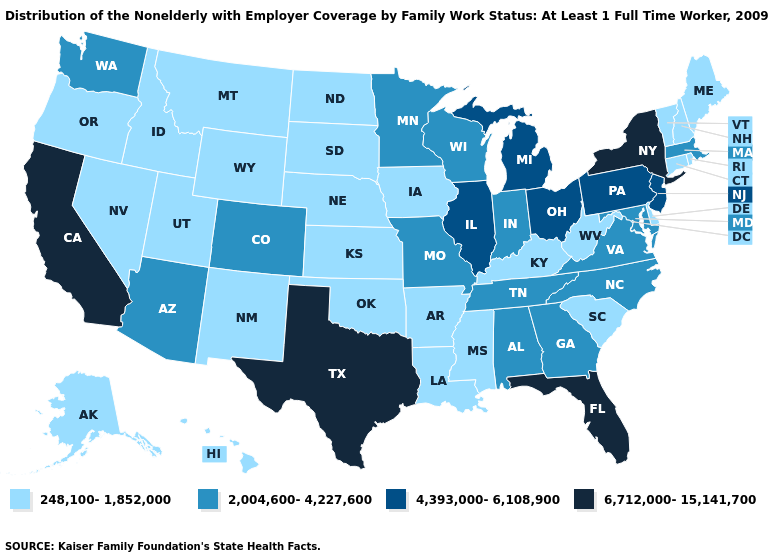Name the states that have a value in the range 248,100-1,852,000?
Short answer required. Alaska, Arkansas, Connecticut, Delaware, Hawaii, Idaho, Iowa, Kansas, Kentucky, Louisiana, Maine, Mississippi, Montana, Nebraska, Nevada, New Hampshire, New Mexico, North Dakota, Oklahoma, Oregon, Rhode Island, South Carolina, South Dakota, Utah, Vermont, West Virginia, Wyoming. Does the map have missing data?
Answer briefly. No. Does Delaware have the highest value in the South?
Short answer required. No. Which states have the highest value in the USA?
Short answer required. California, Florida, New York, Texas. Name the states that have a value in the range 248,100-1,852,000?
Write a very short answer. Alaska, Arkansas, Connecticut, Delaware, Hawaii, Idaho, Iowa, Kansas, Kentucky, Louisiana, Maine, Mississippi, Montana, Nebraska, Nevada, New Hampshire, New Mexico, North Dakota, Oklahoma, Oregon, Rhode Island, South Carolina, South Dakota, Utah, Vermont, West Virginia, Wyoming. What is the value of Arizona?
Short answer required. 2,004,600-4,227,600. Among the states that border New Mexico , does Oklahoma have the lowest value?
Answer briefly. Yes. Does West Virginia have a higher value than Montana?
Write a very short answer. No. Name the states that have a value in the range 248,100-1,852,000?
Short answer required. Alaska, Arkansas, Connecticut, Delaware, Hawaii, Idaho, Iowa, Kansas, Kentucky, Louisiana, Maine, Mississippi, Montana, Nebraska, Nevada, New Hampshire, New Mexico, North Dakota, Oklahoma, Oregon, Rhode Island, South Carolina, South Dakota, Utah, Vermont, West Virginia, Wyoming. Does Oklahoma have the highest value in the USA?
Write a very short answer. No. Name the states that have a value in the range 4,393,000-6,108,900?
Concise answer only. Illinois, Michigan, New Jersey, Ohio, Pennsylvania. Among the states that border Utah , does Colorado have the highest value?
Short answer required. Yes. What is the highest value in the USA?
Concise answer only. 6,712,000-15,141,700. Name the states that have a value in the range 6,712,000-15,141,700?
Give a very brief answer. California, Florida, New York, Texas. What is the value of New Jersey?
Give a very brief answer. 4,393,000-6,108,900. 